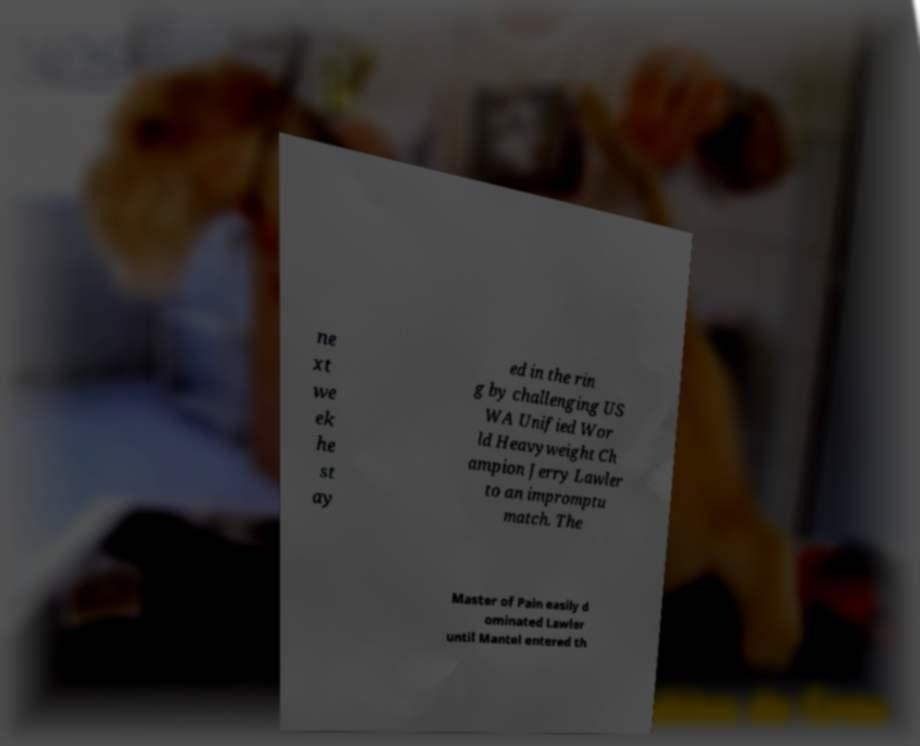What messages or text are displayed in this image? I need them in a readable, typed format. ne xt we ek he st ay ed in the rin g by challenging US WA Unified Wor ld Heavyweight Ch ampion Jerry Lawler to an impromptu match. The Master of Pain easily d ominated Lawler until Mantel entered th 